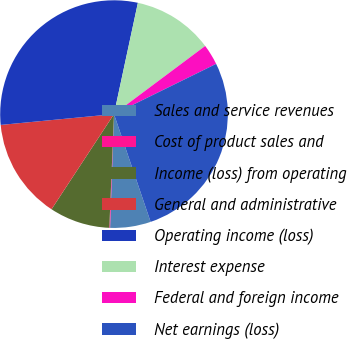Convert chart to OTSL. <chart><loc_0><loc_0><loc_500><loc_500><pie_chart><fcel>Sales and service revenues<fcel>Cost of product sales and<fcel>Income (loss) from operating<fcel>General and administrative<fcel>Operating income (loss)<fcel>Interest expense<fcel>Federal and foreign income<fcel>Net earnings (loss)<nl><fcel>5.76%<fcel>0.11%<fcel>8.59%<fcel>14.24%<fcel>29.88%<fcel>11.42%<fcel>2.94%<fcel>27.06%<nl></chart> 